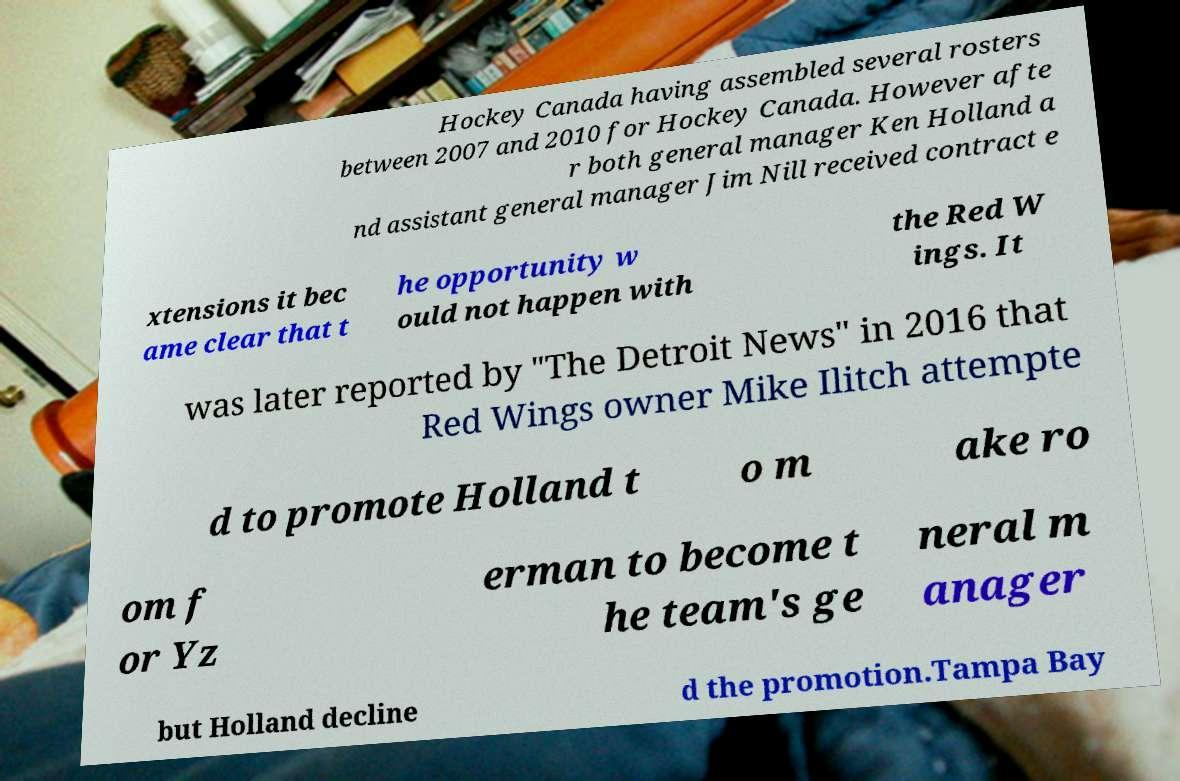What messages or text are displayed in this image? I need them in a readable, typed format. Hockey Canada having assembled several rosters between 2007 and 2010 for Hockey Canada. However afte r both general manager Ken Holland a nd assistant general manager Jim Nill received contract e xtensions it bec ame clear that t he opportunity w ould not happen with the Red W ings. It was later reported by "The Detroit News" in 2016 that Red Wings owner Mike Ilitch attempte d to promote Holland t o m ake ro om f or Yz erman to become t he team's ge neral m anager but Holland decline d the promotion.Tampa Bay 